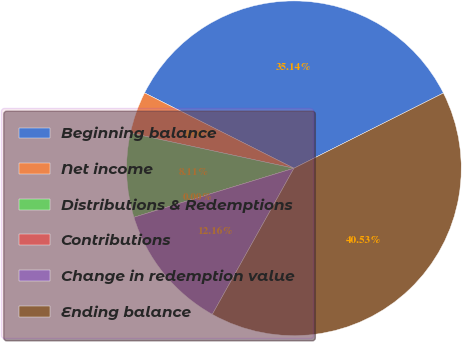Convert chart. <chart><loc_0><loc_0><loc_500><loc_500><pie_chart><fcel>Beginning balance<fcel>Net income<fcel>Distributions & Redemptions<fcel>Contributions<fcel>Change in redemption value<fcel>Ending balance<nl><fcel>35.14%<fcel>4.06%<fcel>8.11%<fcel>0.0%<fcel>12.16%<fcel>40.53%<nl></chart> 